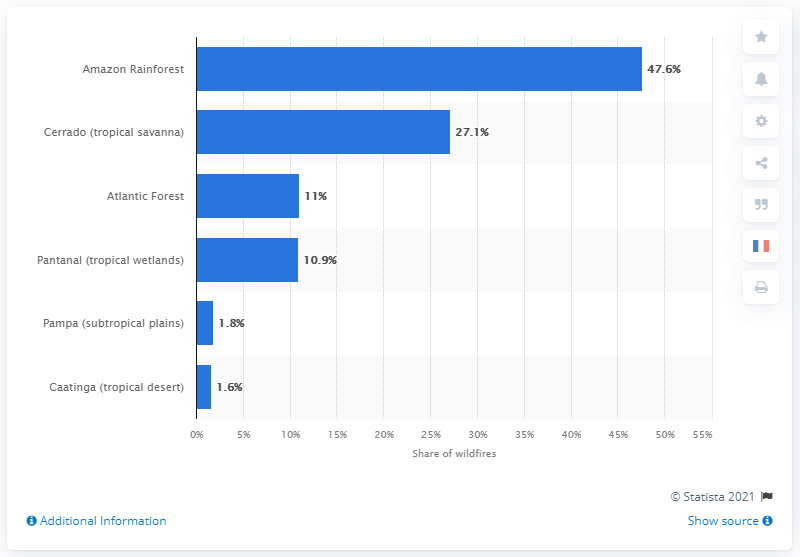Give some essential details in this illustration. According to the data, approximately 11% of the fires occurred in the Atlantic forest region. 